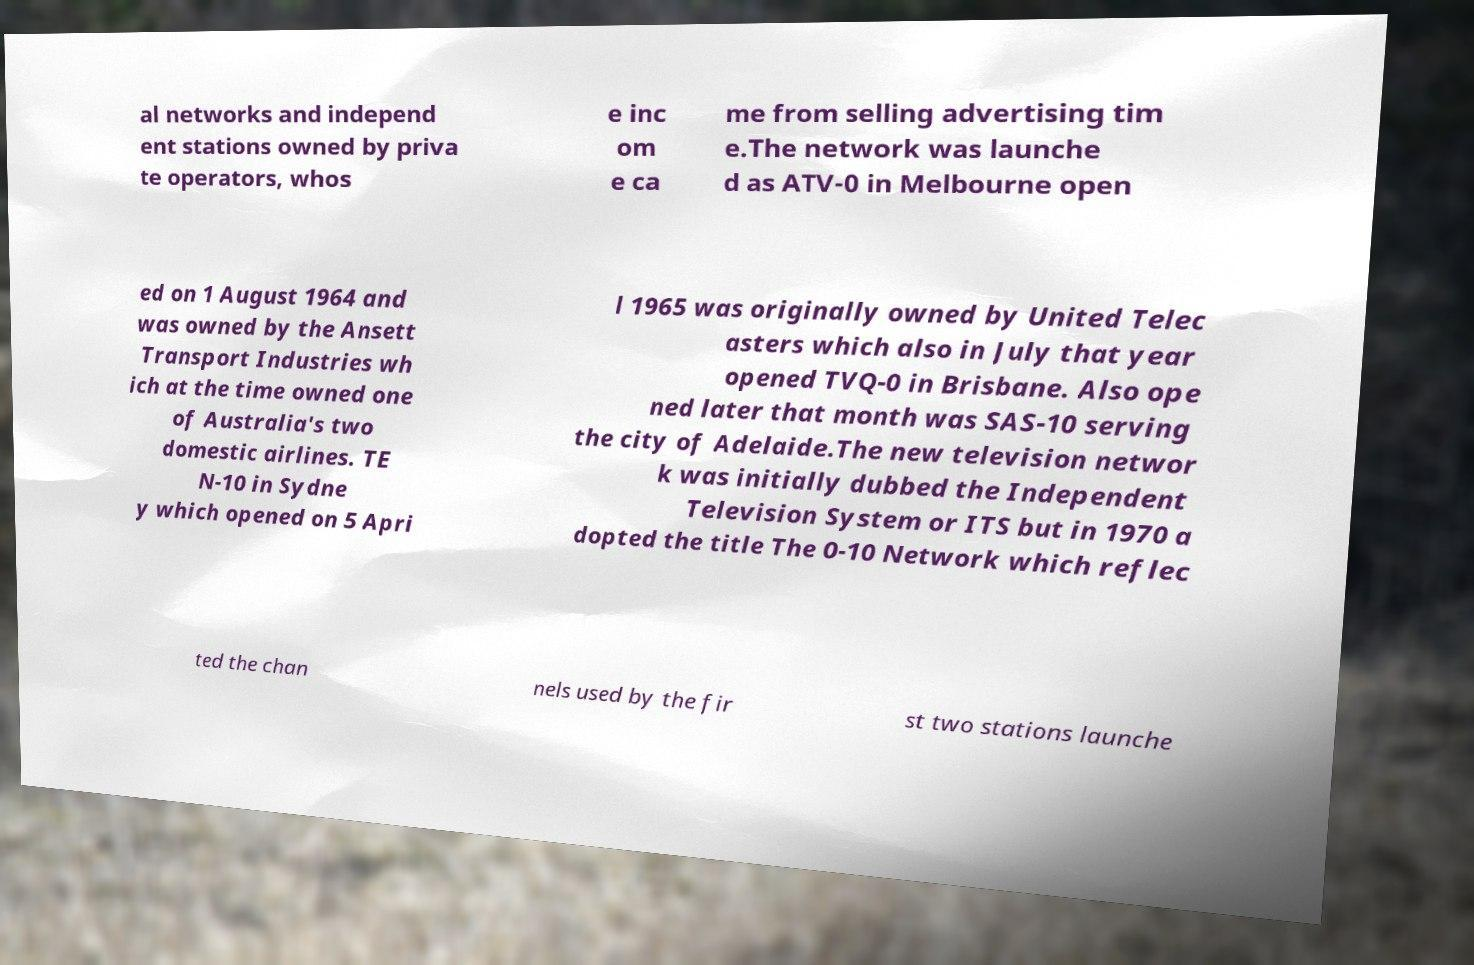Could you extract and type out the text from this image? al networks and independ ent stations owned by priva te operators, whos e inc om e ca me from selling advertising tim e.The network was launche d as ATV-0 in Melbourne open ed on 1 August 1964 and was owned by the Ansett Transport Industries wh ich at the time owned one of Australia's two domestic airlines. TE N-10 in Sydne y which opened on 5 Apri l 1965 was originally owned by United Telec asters which also in July that year opened TVQ-0 in Brisbane. Also ope ned later that month was SAS-10 serving the city of Adelaide.The new television networ k was initially dubbed the Independent Television System or ITS but in 1970 a dopted the title The 0-10 Network which reflec ted the chan nels used by the fir st two stations launche 